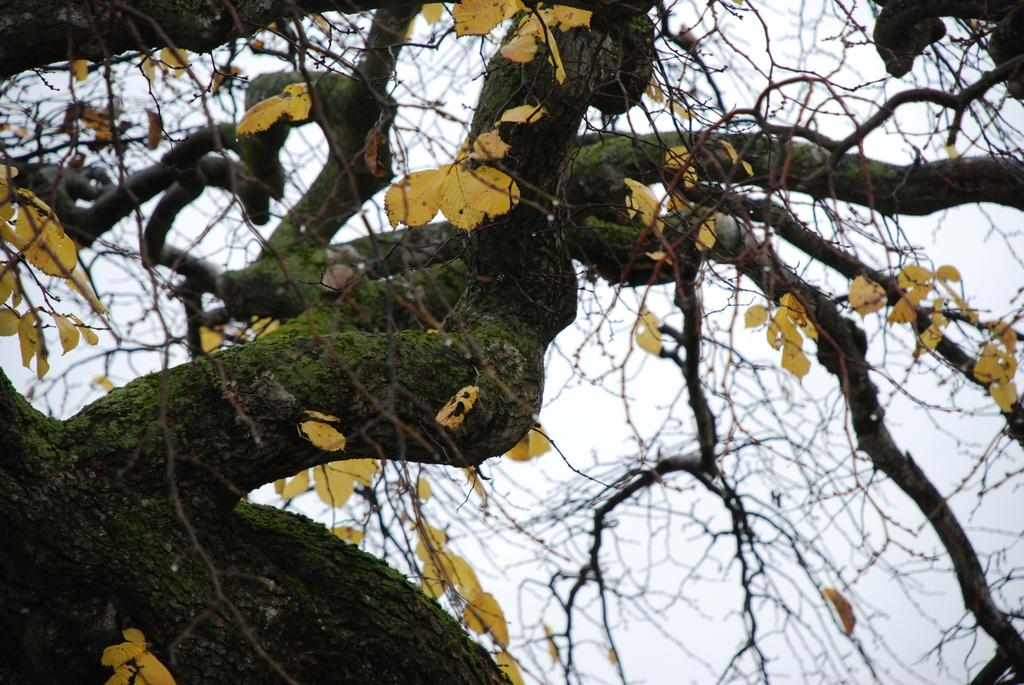What is the main subject of the image? The main subject of the image is a tree. What is unique about the tree's appearance? The tree has yellow color leaves. Are there any other elements present on the tree? Yes, there is algae on the tree. What can be seen above the tree in the image? The sky is visible above the tree. What type of bells can be heard ringing in the image? There are no bells present in the image, and therefore no sound can be heard. Where is the secretary located in the image? There is no secretary present in the image. 